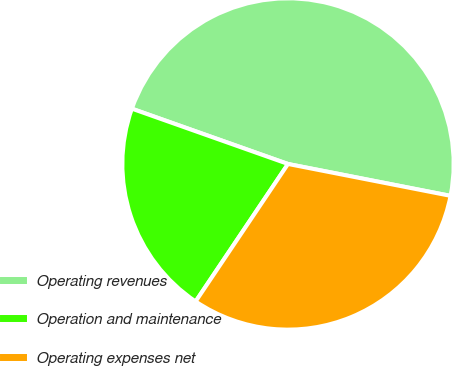<chart> <loc_0><loc_0><loc_500><loc_500><pie_chart><fcel>Operating revenues<fcel>Operation and maintenance<fcel>Operating expenses net<nl><fcel>47.66%<fcel>21.0%<fcel>31.33%<nl></chart> 